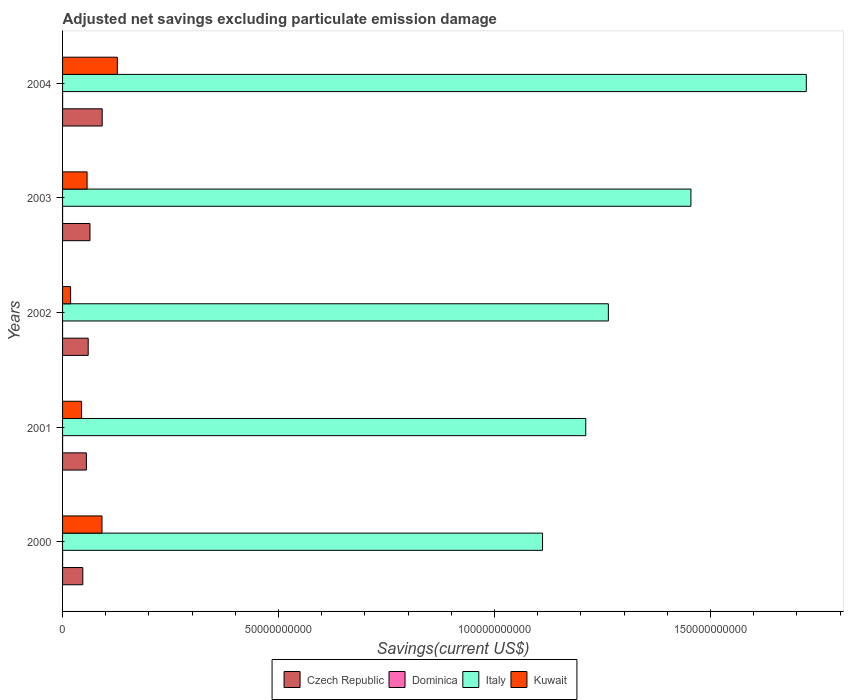In how many cases, is the number of bars for a given year not equal to the number of legend labels?
Ensure brevity in your answer.  1. What is the adjusted net savings in Kuwait in 2004?
Provide a short and direct response. 1.27e+1. Across all years, what is the maximum adjusted net savings in Dominica?
Your answer should be compact. 6.87e+06. In which year was the adjusted net savings in Italy maximum?
Provide a succinct answer. 2004. What is the total adjusted net savings in Kuwait in the graph?
Provide a succinct answer. 3.37e+1. What is the difference between the adjusted net savings in Kuwait in 2003 and that in 2004?
Give a very brief answer. -7.00e+09. What is the difference between the adjusted net savings in Kuwait in 2000 and the adjusted net savings in Dominica in 2003?
Provide a short and direct response. 9.13e+09. What is the average adjusted net savings in Kuwait per year?
Your answer should be very brief. 6.75e+09. In the year 2004, what is the difference between the adjusted net savings in Dominica and adjusted net savings in Kuwait?
Provide a short and direct response. -1.27e+1. What is the ratio of the adjusted net savings in Dominica in 2000 to that in 2001?
Ensure brevity in your answer.  6.02. Is the difference between the adjusted net savings in Dominica in 2000 and 2001 greater than the difference between the adjusted net savings in Kuwait in 2000 and 2001?
Your answer should be compact. No. What is the difference between the highest and the second highest adjusted net savings in Kuwait?
Offer a very short reply. 3.55e+09. What is the difference between the highest and the lowest adjusted net savings in Dominica?
Ensure brevity in your answer.  6.87e+06. In how many years, is the adjusted net savings in Czech Republic greater than the average adjusted net savings in Czech Republic taken over all years?
Provide a succinct answer. 2. Is it the case that in every year, the sum of the adjusted net savings in Kuwait and adjusted net savings in Italy is greater than the sum of adjusted net savings in Dominica and adjusted net savings in Czech Republic?
Provide a short and direct response. Yes. Is it the case that in every year, the sum of the adjusted net savings in Dominica and adjusted net savings in Italy is greater than the adjusted net savings in Czech Republic?
Make the answer very short. Yes. How many bars are there?
Keep it short and to the point. 19. Are all the bars in the graph horizontal?
Ensure brevity in your answer.  Yes. How many years are there in the graph?
Provide a short and direct response. 5. What is the difference between two consecutive major ticks on the X-axis?
Your response must be concise. 5.00e+1. Are the values on the major ticks of X-axis written in scientific E-notation?
Ensure brevity in your answer.  No. Does the graph contain any zero values?
Make the answer very short. Yes. Does the graph contain grids?
Provide a succinct answer. No. What is the title of the graph?
Provide a short and direct response. Adjusted net savings excluding particulate emission damage. Does "Benin" appear as one of the legend labels in the graph?
Make the answer very short. No. What is the label or title of the X-axis?
Provide a short and direct response. Savings(current US$). What is the Savings(current US$) of Czech Republic in 2000?
Make the answer very short. 4.69e+09. What is the Savings(current US$) of Dominica in 2000?
Your answer should be very brief. 6.87e+06. What is the Savings(current US$) in Italy in 2000?
Your answer should be very brief. 1.11e+11. What is the Savings(current US$) in Kuwait in 2000?
Provide a succinct answer. 9.13e+09. What is the Savings(current US$) in Czech Republic in 2001?
Ensure brevity in your answer.  5.52e+09. What is the Savings(current US$) of Dominica in 2001?
Your answer should be very brief. 1.14e+06. What is the Savings(current US$) in Italy in 2001?
Give a very brief answer. 1.21e+11. What is the Savings(current US$) in Kuwait in 2001?
Your answer should be very brief. 4.39e+09. What is the Savings(current US$) in Czech Republic in 2002?
Provide a succinct answer. 5.94e+09. What is the Savings(current US$) of Dominica in 2002?
Give a very brief answer. 0. What is the Savings(current US$) in Italy in 2002?
Offer a very short reply. 1.26e+11. What is the Savings(current US$) in Kuwait in 2002?
Offer a very short reply. 1.86e+09. What is the Savings(current US$) of Czech Republic in 2003?
Ensure brevity in your answer.  6.35e+09. What is the Savings(current US$) of Dominica in 2003?
Your response must be concise. 1.30e+06. What is the Savings(current US$) in Italy in 2003?
Keep it short and to the point. 1.45e+11. What is the Savings(current US$) of Kuwait in 2003?
Make the answer very short. 5.68e+09. What is the Savings(current US$) of Czech Republic in 2004?
Your answer should be very brief. 9.17e+09. What is the Savings(current US$) in Dominica in 2004?
Offer a very short reply. 5.61e+06. What is the Savings(current US$) in Italy in 2004?
Keep it short and to the point. 1.72e+11. What is the Savings(current US$) in Kuwait in 2004?
Provide a succinct answer. 1.27e+1. Across all years, what is the maximum Savings(current US$) in Czech Republic?
Ensure brevity in your answer.  9.17e+09. Across all years, what is the maximum Savings(current US$) in Dominica?
Your answer should be compact. 6.87e+06. Across all years, what is the maximum Savings(current US$) in Italy?
Give a very brief answer. 1.72e+11. Across all years, what is the maximum Savings(current US$) of Kuwait?
Your answer should be compact. 1.27e+1. Across all years, what is the minimum Savings(current US$) of Czech Republic?
Provide a short and direct response. 4.69e+09. Across all years, what is the minimum Savings(current US$) in Italy?
Give a very brief answer. 1.11e+11. Across all years, what is the minimum Savings(current US$) in Kuwait?
Keep it short and to the point. 1.86e+09. What is the total Savings(current US$) of Czech Republic in the graph?
Make the answer very short. 3.17e+1. What is the total Savings(current US$) in Dominica in the graph?
Give a very brief answer. 1.49e+07. What is the total Savings(current US$) of Italy in the graph?
Your response must be concise. 6.76e+11. What is the total Savings(current US$) of Kuwait in the graph?
Provide a short and direct response. 3.37e+1. What is the difference between the Savings(current US$) of Czech Republic in 2000 and that in 2001?
Keep it short and to the point. -8.30e+08. What is the difference between the Savings(current US$) of Dominica in 2000 and that in 2001?
Your response must be concise. 5.73e+06. What is the difference between the Savings(current US$) of Italy in 2000 and that in 2001?
Provide a succinct answer. -1.00e+1. What is the difference between the Savings(current US$) in Kuwait in 2000 and that in 2001?
Ensure brevity in your answer.  4.74e+09. What is the difference between the Savings(current US$) of Czech Republic in 2000 and that in 2002?
Ensure brevity in your answer.  -1.25e+09. What is the difference between the Savings(current US$) of Italy in 2000 and that in 2002?
Provide a succinct answer. -1.52e+1. What is the difference between the Savings(current US$) in Kuwait in 2000 and that in 2002?
Make the answer very short. 7.27e+09. What is the difference between the Savings(current US$) in Czech Republic in 2000 and that in 2003?
Your answer should be very brief. -1.66e+09. What is the difference between the Savings(current US$) in Dominica in 2000 and that in 2003?
Offer a terse response. 5.56e+06. What is the difference between the Savings(current US$) of Italy in 2000 and that in 2003?
Keep it short and to the point. -3.44e+1. What is the difference between the Savings(current US$) in Kuwait in 2000 and that in 2003?
Give a very brief answer. 3.45e+09. What is the difference between the Savings(current US$) in Czech Republic in 2000 and that in 2004?
Offer a terse response. -4.48e+09. What is the difference between the Savings(current US$) of Dominica in 2000 and that in 2004?
Your answer should be compact. 1.26e+06. What is the difference between the Savings(current US$) of Italy in 2000 and that in 2004?
Give a very brief answer. -6.11e+1. What is the difference between the Savings(current US$) of Kuwait in 2000 and that in 2004?
Your answer should be very brief. -3.55e+09. What is the difference between the Savings(current US$) of Czech Republic in 2001 and that in 2002?
Offer a very short reply. -4.19e+08. What is the difference between the Savings(current US$) in Italy in 2001 and that in 2002?
Give a very brief answer. -5.23e+09. What is the difference between the Savings(current US$) of Kuwait in 2001 and that in 2002?
Your response must be concise. 2.53e+09. What is the difference between the Savings(current US$) in Czech Republic in 2001 and that in 2003?
Ensure brevity in your answer.  -8.33e+08. What is the difference between the Savings(current US$) of Dominica in 2001 and that in 2003?
Give a very brief answer. -1.62e+05. What is the difference between the Savings(current US$) of Italy in 2001 and that in 2003?
Provide a succinct answer. -2.43e+1. What is the difference between the Savings(current US$) in Kuwait in 2001 and that in 2003?
Provide a succinct answer. -1.29e+09. What is the difference between the Savings(current US$) in Czech Republic in 2001 and that in 2004?
Make the answer very short. -3.66e+09. What is the difference between the Savings(current US$) of Dominica in 2001 and that in 2004?
Provide a succinct answer. -4.47e+06. What is the difference between the Savings(current US$) of Italy in 2001 and that in 2004?
Keep it short and to the point. -5.11e+1. What is the difference between the Savings(current US$) of Kuwait in 2001 and that in 2004?
Your answer should be very brief. -8.28e+09. What is the difference between the Savings(current US$) in Czech Republic in 2002 and that in 2003?
Offer a very short reply. -4.13e+08. What is the difference between the Savings(current US$) of Italy in 2002 and that in 2003?
Give a very brief answer. -1.91e+1. What is the difference between the Savings(current US$) in Kuwait in 2002 and that in 2003?
Ensure brevity in your answer.  -3.82e+09. What is the difference between the Savings(current US$) in Czech Republic in 2002 and that in 2004?
Your answer should be compact. -3.24e+09. What is the difference between the Savings(current US$) of Italy in 2002 and that in 2004?
Provide a succinct answer. -4.58e+1. What is the difference between the Savings(current US$) of Kuwait in 2002 and that in 2004?
Your answer should be very brief. -1.08e+1. What is the difference between the Savings(current US$) of Czech Republic in 2003 and that in 2004?
Provide a succinct answer. -2.82e+09. What is the difference between the Savings(current US$) of Dominica in 2003 and that in 2004?
Ensure brevity in your answer.  -4.30e+06. What is the difference between the Savings(current US$) of Italy in 2003 and that in 2004?
Provide a succinct answer. -2.67e+1. What is the difference between the Savings(current US$) in Kuwait in 2003 and that in 2004?
Offer a very short reply. -7.00e+09. What is the difference between the Savings(current US$) of Czech Republic in 2000 and the Savings(current US$) of Dominica in 2001?
Give a very brief answer. 4.69e+09. What is the difference between the Savings(current US$) of Czech Republic in 2000 and the Savings(current US$) of Italy in 2001?
Ensure brevity in your answer.  -1.16e+11. What is the difference between the Savings(current US$) in Czech Republic in 2000 and the Savings(current US$) in Kuwait in 2001?
Your answer should be very brief. 2.94e+08. What is the difference between the Savings(current US$) in Dominica in 2000 and the Savings(current US$) in Italy in 2001?
Ensure brevity in your answer.  -1.21e+11. What is the difference between the Savings(current US$) of Dominica in 2000 and the Savings(current US$) of Kuwait in 2001?
Your answer should be compact. -4.39e+09. What is the difference between the Savings(current US$) in Italy in 2000 and the Savings(current US$) in Kuwait in 2001?
Offer a very short reply. 1.07e+11. What is the difference between the Savings(current US$) in Czech Republic in 2000 and the Savings(current US$) in Italy in 2002?
Give a very brief answer. -1.22e+11. What is the difference between the Savings(current US$) in Czech Republic in 2000 and the Savings(current US$) in Kuwait in 2002?
Your answer should be compact. 2.82e+09. What is the difference between the Savings(current US$) in Dominica in 2000 and the Savings(current US$) in Italy in 2002?
Ensure brevity in your answer.  -1.26e+11. What is the difference between the Savings(current US$) in Dominica in 2000 and the Savings(current US$) in Kuwait in 2002?
Give a very brief answer. -1.85e+09. What is the difference between the Savings(current US$) in Italy in 2000 and the Savings(current US$) in Kuwait in 2002?
Provide a succinct answer. 1.09e+11. What is the difference between the Savings(current US$) in Czech Republic in 2000 and the Savings(current US$) in Dominica in 2003?
Offer a very short reply. 4.69e+09. What is the difference between the Savings(current US$) of Czech Republic in 2000 and the Savings(current US$) of Italy in 2003?
Your answer should be very brief. -1.41e+11. What is the difference between the Savings(current US$) in Czech Republic in 2000 and the Savings(current US$) in Kuwait in 2003?
Provide a succinct answer. -9.91e+08. What is the difference between the Savings(current US$) of Dominica in 2000 and the Savings(current US$) of Italy in 2003?
Your answer should be compact. -1.45e+11. What is the difference between the Savings(current US$) of Dominica in 2000 and the Savings(current US$) of Kuwait in 2003?
Your answer should be compact. -5.67e+09. What is the difference between the Savings(current US$) of Italy in 2000 and the Savings(current US$) of Kuwait in 2003?
Offer a very short reply. 1.05e+11. What is the difference between the Savings(current US$) in Czech Republic in 2000 and the Savings(current US$) in Dominica in 2004?
Give a very brief answer. 4.68e+09. What is the difference between the Savings(current US$) of Czech Republic in 2000 and the Savings(current US$) of Italy in 2004?
Make the answer very short. -1.67e+11. What is the difference between the Savings(current US$) in Czech Republic in 2000 and the Savings(current US$) in Kuwait in 2004?
Provide a succinct answer. -7.99e+09. What is the difference between the Savings(current US$) of Dominica in 2000 and the Savings(current US$) of Italy in 2004?
Offer a terse response. -1.72e+11. What is the difference between the Savings(current US$) in Dominica in 2000 and the Savings(current US$) in Kuwait in 2004?
Make the answer very short. -1.27e+1. What is the difference between the Savings(current US$) of Italy in 2000 and the Savings(current US$) of Kuwait in 2004?
Your answer should be very brief. 9.84e+1. What is the difference between the Savings(current US$) of Czech Republic in 2001 and the Savings(current US$) of Italy in 2002?
Offer a terse response. -1.21e+11. What is the difference between the Savings(current US$) of Czech Republic in 2001 and the Savings(current US$) of Kuwait in 2002?
Ensure brevity in your answer.  3.65e+09. What is the difference between the Savings(current US$) of Dominica in 2001 and the Savings(current US$) of Italy in 2002?
Offer a very short reply. -1.26e+11. What is the difference between the Savings(current US$) in Dominica in 2001 and the Savings(current US$) in Kuwait in 2002?
Give a very brief answer. -1.86e+09. What is the difference between the Savings(current US$) of Italy in 2001 and the Savings(current US$) of Kuwait in 2002?
Your answer should be very brief. 1.19e+11. What is the difference between the Savings(current US$) of Czech Republic in 2001 and the Savings(current US$) of Dominica in 2003?
Your answer should be very brief. 5.51e+09. What is the difference between the Savings(current US$) in Czech Republic in 2001 and the Savings(current US$) in Italy in 2003?
Make the answer very short. -1.40e+11. What is the difference between the Savings(current US$) in Czech Republic in 2001 and the Savings(current US$) in Kuwait in 2003?
Offer a very short reply. -1.62e+08. What is the difference between the Savings(current US$) in Dominica in 2001 and the Savings(current US$) in Italy in 2003?
Provide a succinct answer. -1.45e+11. What is the difference between the Savings(current US$) of Dominica in 2001 and the Savings(current US$) of Kuwait in 2003?
Give a very brief answer. -5.68e+09. What is the difference between the Savings(current US$) in Italy in 2001 and the Savings(current US$) in Kuwait in 2003?
Keep it short and to the point. 1.15e+11. What is the difference between the Savings(current US$) in Czech Republic in 2001 and the Savings(current US$) in Dominica in 2004?
Your answer should be compact. 5.51e+09. What is the difference between the Savings(current US$) in Czech Republic in 2001 and the Savings(current US$) in Italy in 2004?
Your answer should be compact. -1.67e+11. What is the difference between the Savings(current US$) of Czech Republic in 2001 and the Savings(current US$) of Kuwait in 2004?
Keep it short and to the point. -7.16e+09. What is the difference between the Savings(current US$) in Dominica in 2001 and the Savings(current US$) in Italy in 2004?
Offer a very short reply. -1.72e+11. What is the difference between the Savings(current US$) in Dominica in 2001 and the Savings(current US$) in Kuwait in 2004?
Offer a terse response. -1.27e+1. What is the difference between the Savings(current US$) of Italy in 2001 and the Savings(current US$) of Kuwait in 2004?
Offer a terse response. 1.08e+11. What is the difference between the Savings(current US$) of Czech Republic in 2002 and the Savings(current US$) of Dominica in 2003?
Offer a terse response. 5.93e+09. What is the difference between the Savings(current US$) in Czech Republic in 2002 and the Savings(current US$) in Italy in 2003?
Offer a terse response. -1.40e+11. What is the difference between the Savings(current US$) of Czech Republic in 2002 and the Savings(current US$) of Kuwait in 2003?
Offer a very short reply. 2.58e+08. What is the difference between the Savings(current US$) in Italy in 2002 and the Savings(current US$) in Kuwait in 2003?
Your response must be concise. 1.21e+11. What is the difference between the Savings(current US$) in Czech Republic in 2002 and the Savings(current US$) in Dominica in 2004?
Offer a terse response. 5.93e+09. What is the difference between the Savings(current US$) of Czech Republic in 2002 and the Savings(current US$) of Italy in 2004?
Your response must be concise. -1.66e+11. What is the difference between the Savings(current US$) of Czech Republic in 2002 and the Savings(current US$) of Kuwait in 2004?
Your response must be concise. -6.74e+09. What is the difference between the Savings(current US$) in Italy in 2002 and the Savings(current US$) in Kuwait in 2004?
Keep it short and to the point. 1.14e+11. What is the difference between the Savings(current US$) of Czech Republic in 2003 and the Savings(current US$) of Dominica in 2004?
Your answer should be very brief. 6.34e+09. What is the difference between the Savings(current US$) in Czech Republic in 2003 and the Savings(current US$) in Italy in 2004?
Make the answer very short. -1.66e+11. What is the difference between the Savings(current US$) of Czech Republic in 2003 and the Savings(current US$) of Kuwait in 2004?
Your response must be concise. -6.33e+09. What is the difference between the Savings(current US$) in Dominica in 2003 and the Savings(current US$) in Italy in 2004?
Your response must be concise. -1.72e+11. What is the difference between the Savings(current US$) in Dominica in 2003 and the Savings(current US$) in Kuwait in 2004?
Keep it short and to the point. -1.27e+1. What is the difference between the Savings(current US$) in Italy in 2003 and the Savings(current US$) in Kuwait in 2004?
Your answer should be compact. 1.33e+11. What is the average Savings(current US$) in Czech Republic per year?
Provide a short and direct response. 6.33e+09. What is the average Savings(current US$) of Dominica per year?
Make the answer very short. 2.98e+06. What is the average Savings(current US$) of Italy per year?
Make the answer very short. 1.35e+11. What is the average Savings(current US$) of Kuwait per year?
Provide a short and direct response. 6.75e+09. In the year 2000, what is the difference between the Savings(current US$) of Czech Republic and Savings(current US$) of Dominica?
Keep it short and to the point. 4.68e+09. In the year 2000, what is the difference between the Savings(current US$) of Czech Republic and Savings(current US$) of Italy?
Ensure brevity in your answer.  -1.06e+11. In the year 2000, what is the difference between the Savings(current US$) of Czech Republic and Savings(current US$) of Kuwait?
Provide a short and direct response. -4.44e+09. In the year 2000, what is the difference between the Savings(current US$) in Dominica and Savings(current US$) in Italy?
Provide a short and direct response. -1.11e+11. In the year 2000, what is the difference between the Savings(current US$) of Dominica and Savings(current US$) of Kuwait?
Provide a short and direct response. -9.12e+09. In the year 2000, what is the difference between the Savings(current US$) in Italy and Savings(current US$) in Kuwait?
Your answer should be compact. 1.02e+11. In the year 2001, what is the difference between the Savings(current US$) of Czech Republic and Savings(current US$) of Dominica?
Your answer should be very brief. 5.51e+09. In the year 2001, what is the difference between the Savings(current US$) of Czech Republic and Savings(current US$) of Italy?
Provide a short and direct response. -1.16e+11. In the year 2001, what is the difference between the Savings(current US$) of Czech Republic and Savings(current US$) of Kuwait?
Ensure brevity in your answer.  1.12e+09. In the year 2001, what is the difference between the Savings(current US$) in Dominica and Savings(current US$) in Italy?
Make the answer very short. -1.21e+11. In the year 2001, what is the difference between the Savings(current US$) of Dominica and Savings(current US$) of Kuwait?
Keep it short and to the point. -4.39e+09. In the year 2001, what is the difference between the Savings(current US$) in Italy and Savings(current US$) in Kuwait?
Give a very brief answer. 1.17e+11. In the year 2002, what is the difference between the Savings(current US$) in Czech Republic and Savings(current US$) in Italy?
Your answer should be compact. -1.20e+11. In the year 2002, what is the difference between the Savings(current US$) in Czech Republic and Savings(current US$) in Kuwait?
Keep it short and to the point. 4.07e+09. In the year 2002, what is the difference between the Savings(current US$) of Italy and Savings(current US$) of Kuwait?
Make the answer very short. 1.24e+11. In the year 2003, what is the difference between the Savings(current US$) of Czech Republic and Savings(current US$) of Dominica?
Provide a short and direct response. 6.35e+09. In the year 2003, what is the difference between the Savings(current US$) of Czech Republic and Savings(current US$) of Italy?
Your answer should be compact. -1.39e+11. In the year 2003, what is the difference between the Savings(current US$) of Czech Republic and Savings(current US$) of Kuwait?
Your answer should be very brief. 6.71e+08. In the year 2003, what is the difference between the Savings(current US$) in Dominica and Savings(current US$) in Italy?
Your response must be concise. -1.45e+11. In the year 2003, what is the difference between the Savings(current US$) in Dominica and Savings(current US$) in Kuwait?
Your answer should be compact. -5.68e+09. In the year 2003, what is the difference between the Savings(current US$) of Italy and Savings(current US$) of Kuwait?
Ensure brevity in your answer.  1.40e+11. In the year 2004, what is the difference between the Savings(current US$) of Czech Republic and Savings(current US$) of Dominica?
Offer a terse response. 9.17e+09. In the year 2004, what is the difference between the Savings(current US$) in Czech Republic and Savings(current US$) in Italy?
Give a very brief answer. -1.63e+11. In the year 2004, what is the difference between the Savings(current US$) of Czech Republic and Savings(current US$) of Kuwait?
Ensure brevity in your answer.  -3.50e+09. In the year 2004, what is the difference between the Savings(current US$) of Dominica and Savings(current US$) of Italy?
Your answer should be very brief. -1.72e+11. In the year 2004, what is the difference between the Savings(current US$) in Dominica and Savings(current US$) in Kuwait?
Provide a short and direct response. -1.27e+1. In the year 2004, what is the difference between the Savings(current US$) of Italy and Savings(current US$) of Kuwait?
Offer a terse response. 1.59e+11. What is the ratio of the Savings(current US$) of Czech Republic in 2000 to that in 2001?
Provide a short and direct response. 0.85. What is the ratio of the Savings(current US$) in Dominica in 2000 to that in 2001?
Offer a very short reply. 6.02. What is the ratio of the Savings(current US$) in Italy in 2000 to that in 2001?
Offer a very short reply. 0.92. What is the ratio of the Savings(current US$) of Kuwait in 2000 to that in 2001?
Offer a terse response. 2.08. What is the ratio of the Savings(current US$) in Czech Republic in 2000 to that in 2002?
Keep it short and to the point. 0.79. What is the ratio of the Savings(current US$) in Italy in 2000 to that in 2002?
Your answer should be very brief. 0.88. What is the ratio of the Savings(current US$) of Kuwait in 2000 to that in 2002?
Offer a terse response. 4.9. What is the ratio of the Savings(current US$) in Czech Republic in 2000 to that in 2003?
Ensure brevity in your answer.  0.74. What is the ratio of the Savings(current US$) of Dominica in 2000 to that in 2003?
Give a very brief answer. 5.27. What is the ratio of the Savings(current US$) of Italy in 2000 to that in 2003?
Ensure brevity in your answer.  0.76. What is the ratio of the Savings(current US$) in Kuwait in 2000 to that in 2003?
Your answer should be very brief. 1.61. What is the ratio of the Savings(current US$) in Czech Republic in 2000 to that in 2004?
Ensure brevity in your answer.  0.51. What is the ratio of the Savings(current US$) of Dominica in 2000 to that in 2004?
Offer a very short reply. 1.22. What is the ratio of the Savings(current US$) in Italy in 2000 to that in 2004?
Ensure brevity in your answer.  0.65. What is the ratio of the Savings(current US$) of Kuwait in 2000 to that in 2004?
Your response must be concise. 0.72. What is the ratio of the Savings(current US$) in Czech Republic in 2001 to that in 2002?
Your answer should be compact. 0.93. What is the ratio of the Savings(current US$) in Italy in 2001 to that in 2002?
Provide a succinct answer. 0.96. What is the ratio of the Savings(current US$) in Kuwait in 2001 to that in 2002?
Keep it short and to the point. 2.36. What is the ratio of the Savings(current US$) in Czech Republic in 2001 to that in 2003?
Your response must be concise. 0.87. What is the ratio of the Savings(current US$) of Dominica in 2001 to that in 2003?
Give a very brief answer. 0.88. What is the ratio of the Savings(current US$) in Italy in 2001 to that in 2003?
Your response must be concise. 0.83. What is the ratio of the Savings(current US$) in Kuwait in 2001 to that in 2003?
Ensure brevity in your answer.  0.77. What is the ratio of the Savings(current US$) of Czech Republic in 2001 to that in 2004?
Provide a succinct answer. 0.6. What is the ratio of the Savings(current US$) in Dominica in 2001 to that in 2004?
Keep it short and to the point. 0.2. What is the ratio of the Savings(current US$) of Italy in 2001 to that in 2004?
Ensure brevity in your answer.  0.7. What is the ratio of the Savings(current US$) of Kuwait in 2001 to that in 2004?
Your answer should be very brief. 0.35. What is the ratio of the Savings(current US$) of Czech Republic in 2002 to that in 2003?
Make the answer very short. 0.93. What is the ratio of the Savings(current US$) in Italy in 2002 to that in 2003?
Keep it short and to the point. 0.87. What is the ratio of the Savings(current US$) in Kuwait in 2002 to that in 2003?
Give a very brief answer. 0.33. What is the ratio of the Savings(current US$) of Czech Republic in 2002 to that in 2004?
Give a very brief answer. 0.65. What is the ratio of the Savings(current US$) in Italy in 2002 to that in 2004?
Offer a very short reply. 0.73. What is the ratio of the Savings(current US$) of Kuwait in 2002 to that in 2004?
Offer a very short reply. 0.15. What is the ratio of the Savings(current US$) in Czech Republic in 2003 to that in 2004?
Offer a very short reply. 0.69. What is the ratio of the Savings(current US$) in Dominica in 2003 to that in 2004?
Provide a short and direct response. 0.23. What is the ratio of the Savings(current US$) in Italy in 2003 to that in 2004?
Offer a very short reply. 0.84. What is the ratio of the Savings(current US$) in Kuwait in 2003 to that in 2004?
Provide a short and direct response. 0.45. What is the difference between the highest and the second highest Savings(current US$) of Czech Republic?
Give a very brief answer. 2.82e+09. What is the difference between the highest and the second highest Savings(current US$) in Dominica?
Your answer should be very brief. 1.26e+06. What is the difference between the highest and the second highest Savings(current US$) of Italy?
Offer a terse response. 2.67e+1. What is the difference between the highest and the second highest Savings(current US$) in Kuwait?
Provide a succinct answer. 3.55e+09. What is the difference between the highest and the lowest Savings(current US$) in Czech Republic?
Give a very brief answer. 4.48e+09. What is the difference between the highest and the lowest Savings(current US$) of Dominica?
Your answer should be compact. 6.87e+06. What is the difference between the highest and the lowest Savings(current US$) of Italy?
Provide a short and direct response. 6.11e+1. What is the difference between the highest and the lowest Savings(current US$) of Kuwait?
Your answer should be very brief. 1.08e+1. 